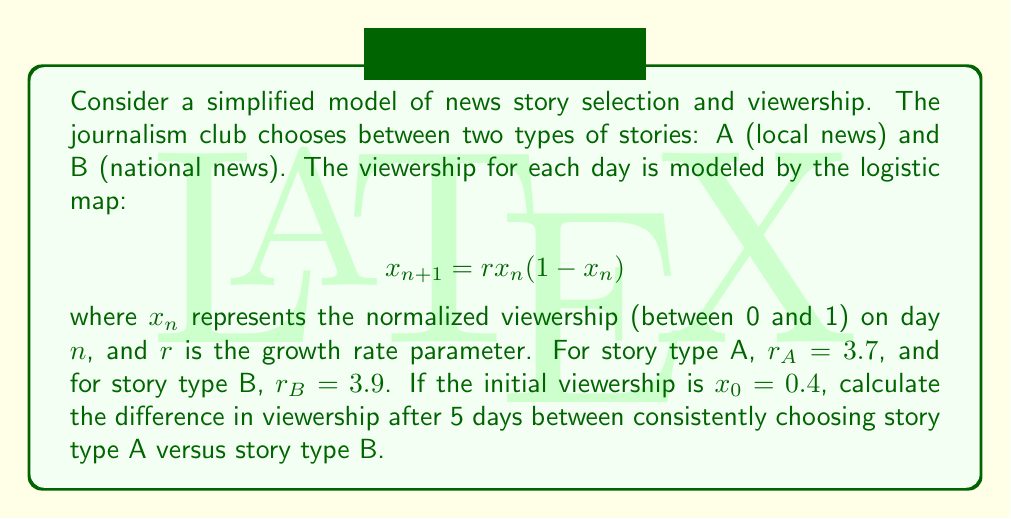Solve this math problem. Let's approach this step-by-step:

1) We need to calculate the viewership for 5 days for both story types A and B.

2) For story type A ($r_A = 3.7$):
   $x_0 = 0.4$
   $x_1 = 3.7 * 0.4 * (1-0.4) = 0.888$
   $x_2 = 3.7 * 0.888 * (1-0.888) = 0.3687$
   $x_3 = 3.7 * 0.3687 * (1-0.3687) = 0.8601$
   $x_4 = 3.7 * 0.8601 * (1-0.8601) = 0.4452$
   $x_5 = 3.7 * 0.4452 * (1-0.4452) = 0.9132$

3) For story type B ($r_B = 3.9$):
   $x_0 = 0.4$
   $x_1 = 3.9 * 0.4 * (1-0.4) = 0.936$
   $x_2 = 3.9 * 0.936 * (1-0.936) = 0.2340$
   $x_3 = 3.9 * 0.2340 * (1-0.2340) = 0.6995$
   $x_4 = 3.9 * 0.6995 * (1-0.6995) = 0.8219$
   $x_5 = 3.9 * 0.8219 * (1-0.8219) = 0.5706$

4) The difference in viewership after 5 days is:
   $|x_5^A - x_5^B| = |0.9132 - 0.5706| = 0.3426$

This significant difference demonstrates the butterfly effect in action, where small initial differences (in this case, the choice of story type) can lead to large divergences over time.
Answer: 0.3426 